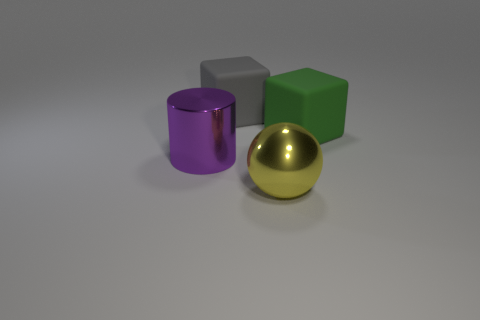Is there anything else of the same color as the big metallic cylinder?
Your response must be concise. No. What is the size of the cube behind the big matte object on the right side of the big gray cube?
Your response must be concise. Large. What color is the large object that is both in front of the large green rubber thing and to the right of the purple metal cylinder?
Offer a terse response. Yellow. What number of other objects are there of the same size as the gray cube?
Offer a very short reply. 3. There is a green rubber cube; is its size the same as the thing that is in front of the shiny cylinder?
Provide a short and direct response. Yes. There is another matte block that is the same size as the gray matte block; what is its color?
Make the answer very short. Green. How big is the purple shiny cylinder?
Provide a succinct answer. Large. Is the sphere on the left side of the big green matte block made of the same material as the purple object?
Your response must be concise. Yes. Is the shape of the yellow thing the same as the big purple object?
Your answer should be compact. No. There is a big rubber thing that is to the left of the big yellow object on the left side of the big rubber block that is on the right side of the yellow metal object; what shape is it?
Give a very brief answer. Cube. 